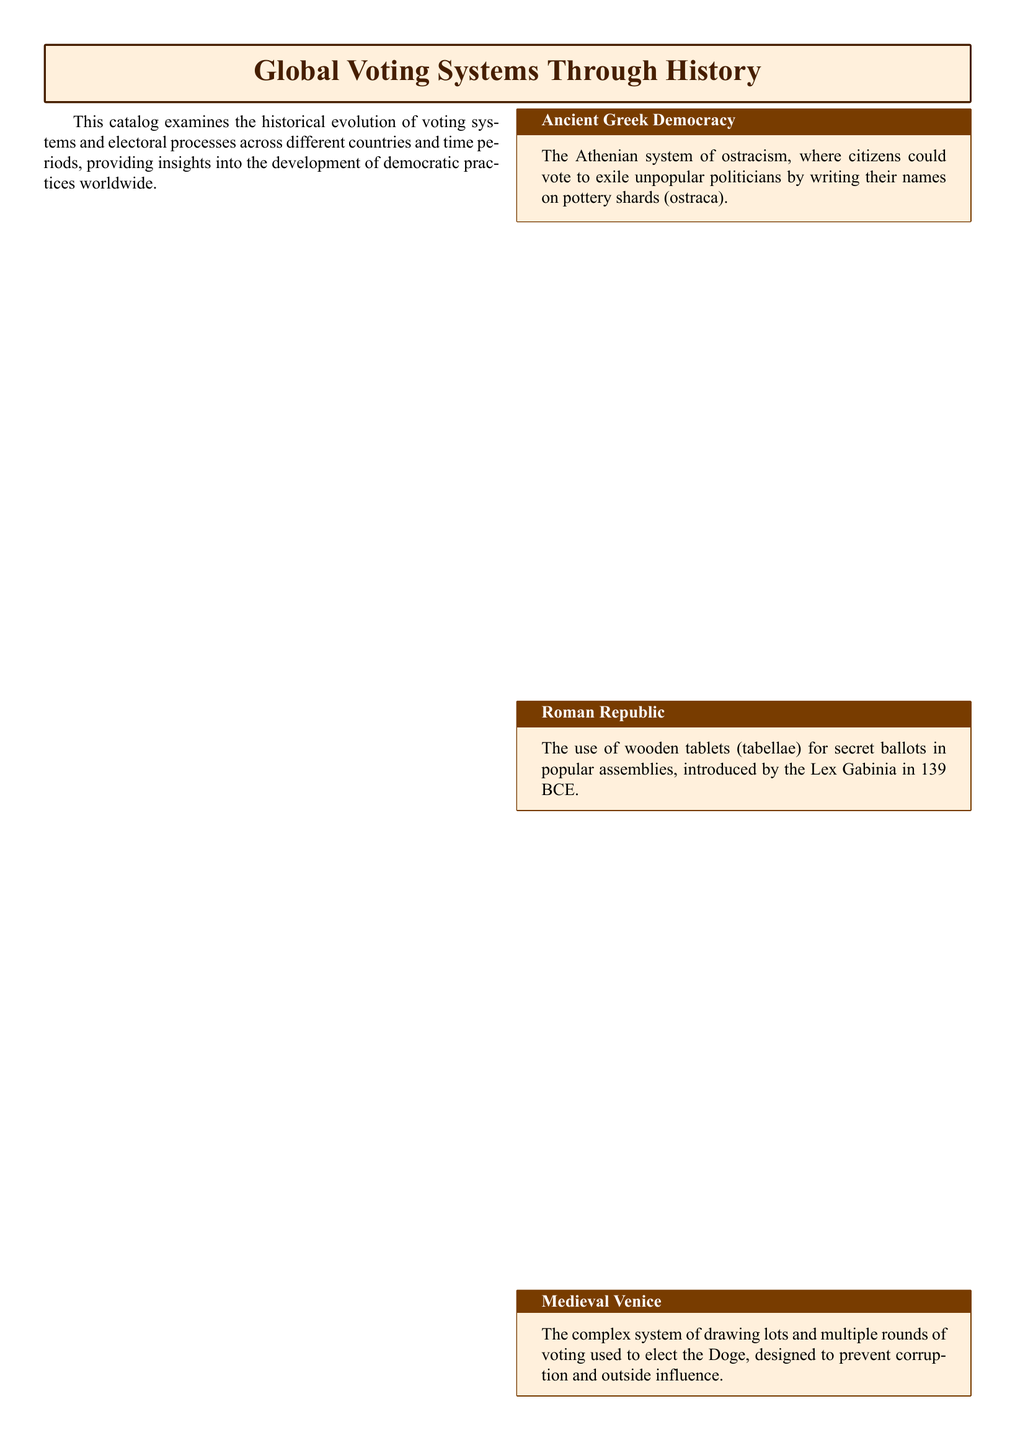What system did the Athenian democracy use to exile politicians? The document states that the Athenian system of ostracism involved writing names on pottery shards (ostraca).
Answer: ostracism What voting method was introduced by the Lex Gabinia? According to the catalog, the Lex Gabinia in 139 BCE introduced the use of wooden tablets (tabellae) for secret ballots.
Answer: wooden tablets Which century saw the transition from voice voting to paper ballots in the United States? The document indicates that this transition occurred in the 19th century.
Answer: 19th century What voting system was adopted by Estonia in 2005? The catalog explains that Estonia implemented an internet voting platform in 2005.
Answer: internet voting platform What method is mentioned as being used in many European countries for proportional representation? The document refers to the D'Hondt method as a proportional representation system adopted in many European countries.
Answer: D'Hondt method What electoral process was designed to prevent corruption in Medieval Venice? The document notes that Medieval Venice used a complex system of drawing lots and multiple rounds of voting.
Answer: drawing lots Which voting system emphasizes fair and efficient electoral processes according to the conclusion? The conclusion states that a diverse range of voting systems reflects changing societal values and technological advancements towards fair electoral processes.
Answer: fair electoral processes How are ballot designs represented in the document? The catalog includes visual representations of ballot designs alongside descriptions of electoral processes.
Answer: visual representations 